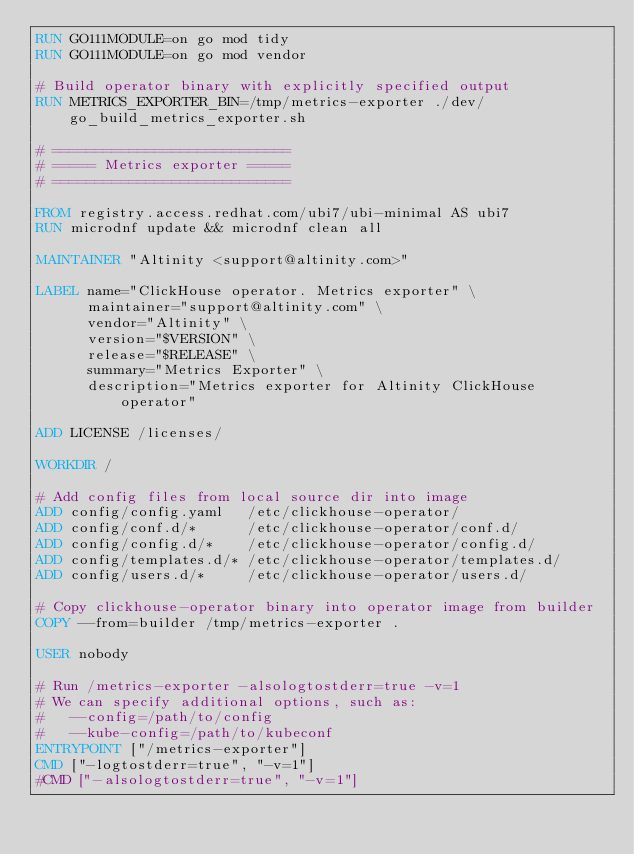Convert code to text. <code><loc_0><loc_0><loc_500><loc_500><_Dockerfile_>RUN GO111MODULE=on go mod tidy
RUN GO111MODULE=on go mod vendor

# Build operator binary with explicitly specified output
RUN METRICS_EXPORTER_BIN=/tmp/metrics-exporter ./dev/go_build_metrics_exporter.sh

# ============================
# ===== Metrics exporter =====
# ============================

FROM registry.access.redhat.com/ubi7/ubi-minimal AS ubi7
RUN microdnf update && microdnf clean all

MAINTAINER "Altinity <support@altinity.com>"

LABEL name="ClickHouse operator. Metrics exporter" \
      maintainer="support@altinity.com" \
      vendor="Altinity" \
      version="$VERSION" \
      release="$RELEASE" \
      summary="Metrics Exporter" \
      description="Metrics exporter for Altinity ClickHouse operator"

ADD LICENSE /licenses/

WORKDIR /

# Add config files from local source dir into image
ADD config/config.yaml   /etc/clickhouse-operator/
ADD config/conf.d/*      /etc/clickhouse-operator/conf.d/
ADD config/config.d/*    /etc/clickhouse-operator/config.d/
ADD config/templates.d/* /etc/clickhouse-operator/templates.d/
ADD config/users.d/*     /etc/clickhouse-operator/users.d/

# Copy clickhouse-operator binary into operator image from builder
COPY --from=builder /tmp/metrics-exporter .

USER nobody

# Run /metrics-exporter -alsologtostderr=true -v=1
# We can specify additional options, such as:
#   --config=/path/to/config
#   --kube-config=/path/to/kubeconf
ENTRYPOINT ["/metrics-exporter"]
CMD ["-logtostderr=true", "-v=1"]
#CMD ["-alsologtostderr=true", "-v=1"]
</code> 